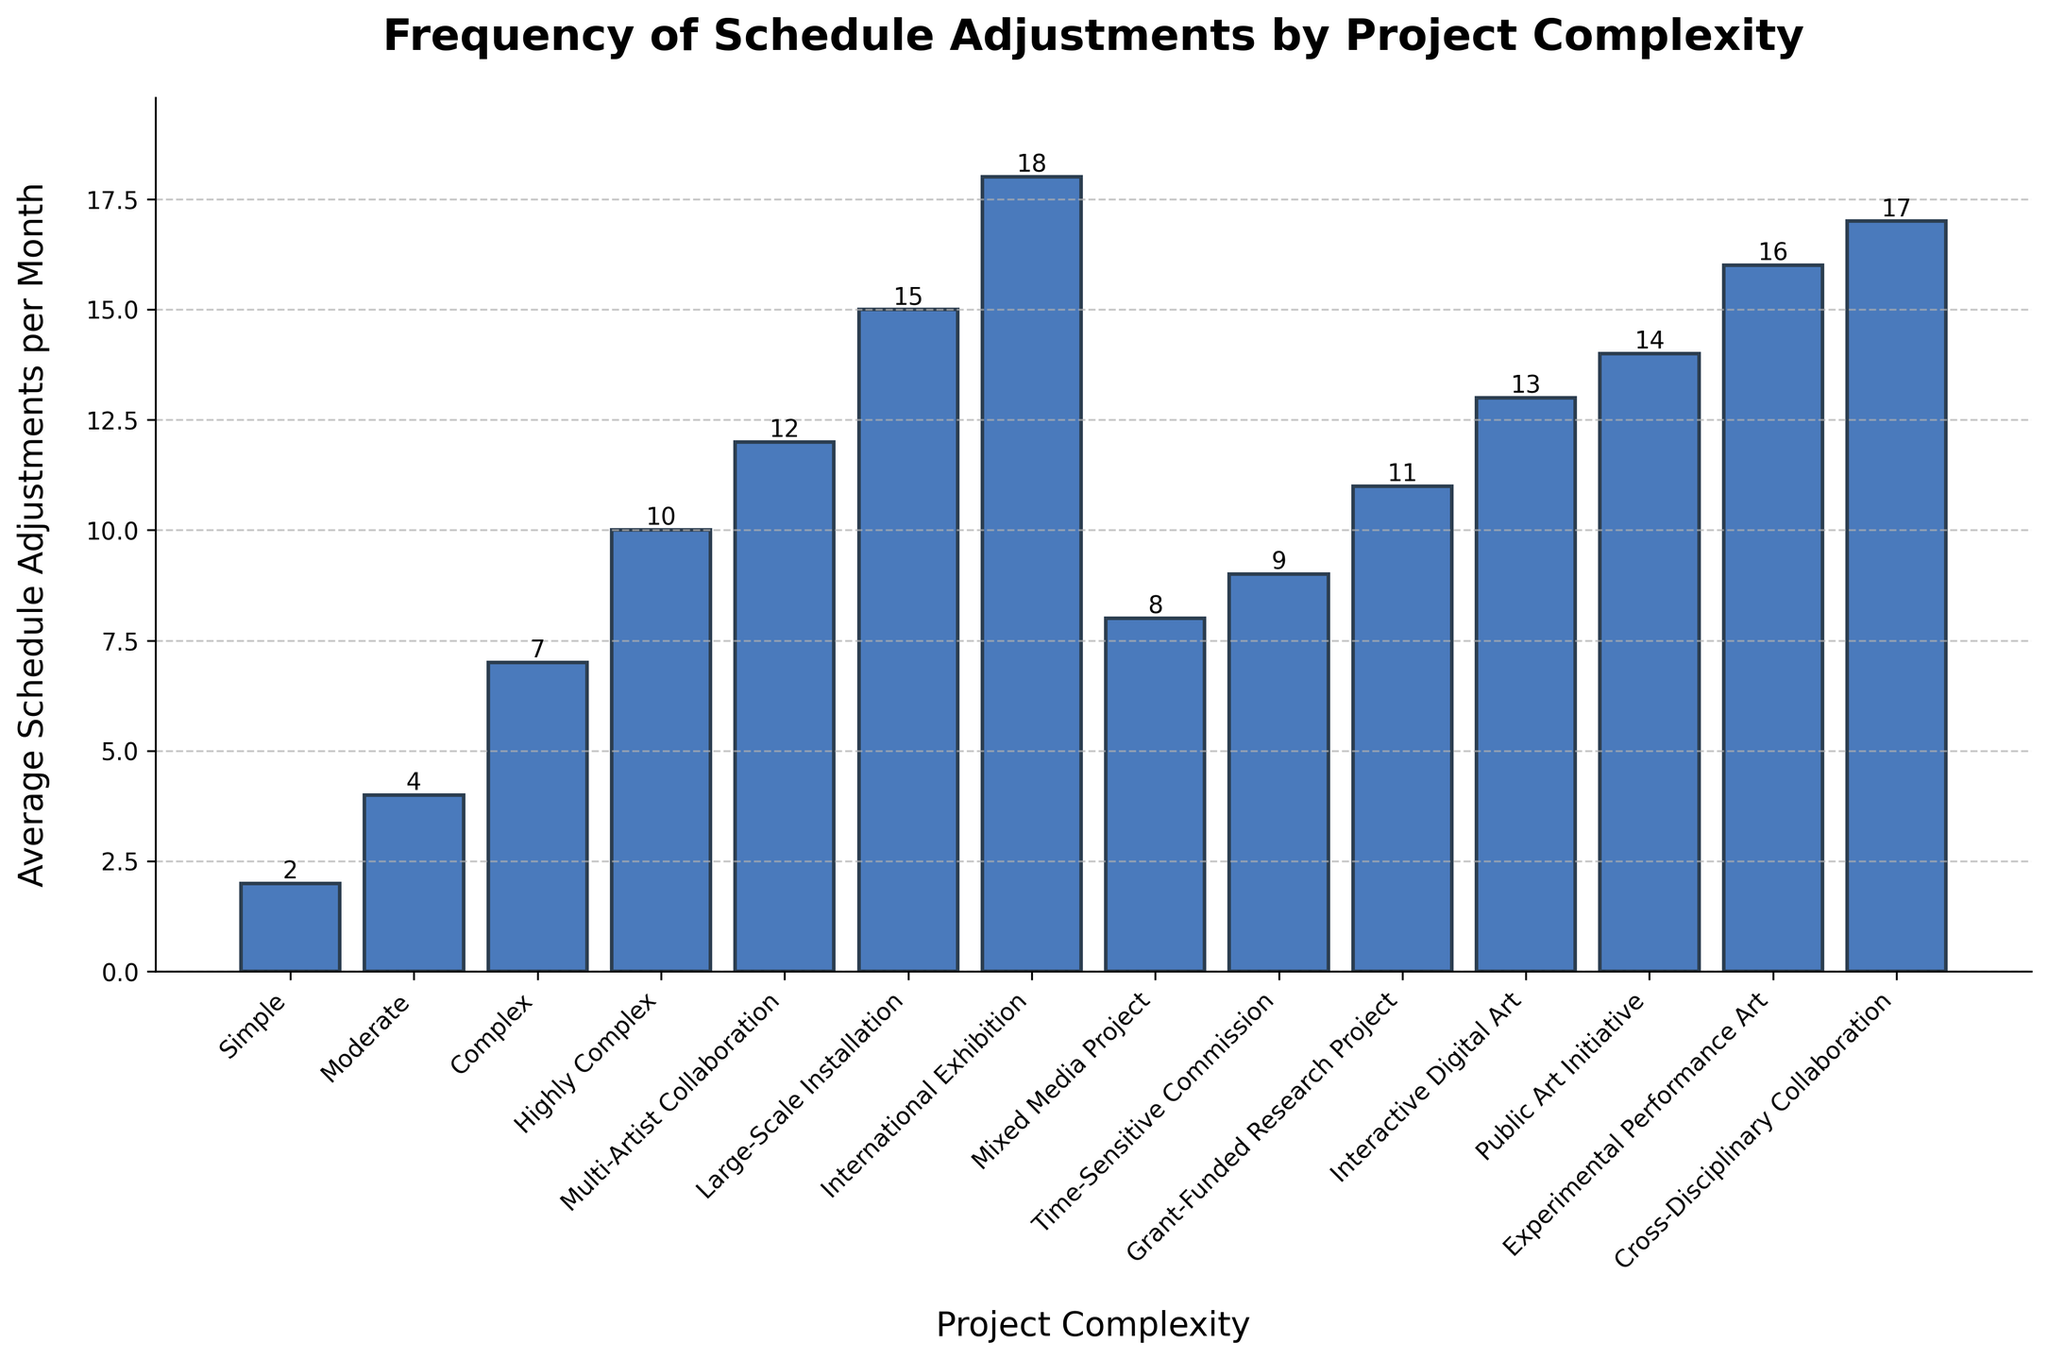What is the average number of schedule adjustments for 'International Exhibition' and 'Grant-Funded Research Project'? Sum the average schedule adjustments for 'International Exhibition' (18) and 'Grant-Funded Research Project' (11), then divide by 2: (18 + 11) / 2 = 14.5
Answer: 14.5 Which project complexity level experiences the highest frequency of schedule adjustments? Identify the bar with the highest value on the y-axis; 'International Exhibition' has the highest value at 18.
Answer: International Exhibition How much higher is the frequency of schedule adjustments for 'Large-Scale Installation' compared to 'Moderate' complexity projects? Subtract the average adjustments for 'Moderate' (4) from 'Large-Scale Installation' (15): 15 - 4 = 11
Answer: 11 Which has more schedule adjustments per month: 'Mixed Media Project' or 'Experimental Performance Art'? Compare the heights of the bars for 'Mixed Media Project' (8) and 'Experimental Performance Art' (16); 'Experimental Performance Art' is higher.
Answer: Experimental Performance Art What is the total number of schedule adjustments for 'Simple' and 'Complex' projects combined? Add the average adjustments for 'Simple' (2) and 'Complex' (7): 2 + 7 = 9
Answer: 9 For which project complexity level(s) are the average schedule adjustments per month 10 or greater? Identify bars where the y-axis value is 10 or greater: 'Highly Complex' (10), 'Grant-Funded Research Project' (11), 'Interactive Digital Art' (13), 'Public Art Initiative' (14), 'Large-Scale Installation' (15), 'Experimental Performance Art' (16), 'Cross-Disciplinary Collaboration' (17), 'International Exhibition' (18), ‘Multi-Artist Collaboration’ (12).
Answer: Highly Complex, Grant-Funded Research Project, Interactive Digital Art, Public Art Initiative, Large-Scale Installation, Experimental Performance Art, Cross-Disciplinary Collaboration, International Exhibition, Multi-Artist Collaboration What is the range of average schedule adjustments for the listed project complexity levels? The range is calculated by subtracting the smallest value (2 for 'Simple') from the largest value (18 for 'International Exhibition'): 18 - 2 = 16
Answer: 16 Which project complexity levels have fewer schedule adjustments per month than 'Time-Sensitive Commission'? 'Time-Sensitive Commission' has 9 adjustments. Project complexity levels with fewer adjustments include: 'Simple' (2), 'Moderate' (4), 'Complex' (7), and 'Mixed Media Project' (8).
Answer: Simple, Moderate, Complex, Mixed Media Project 